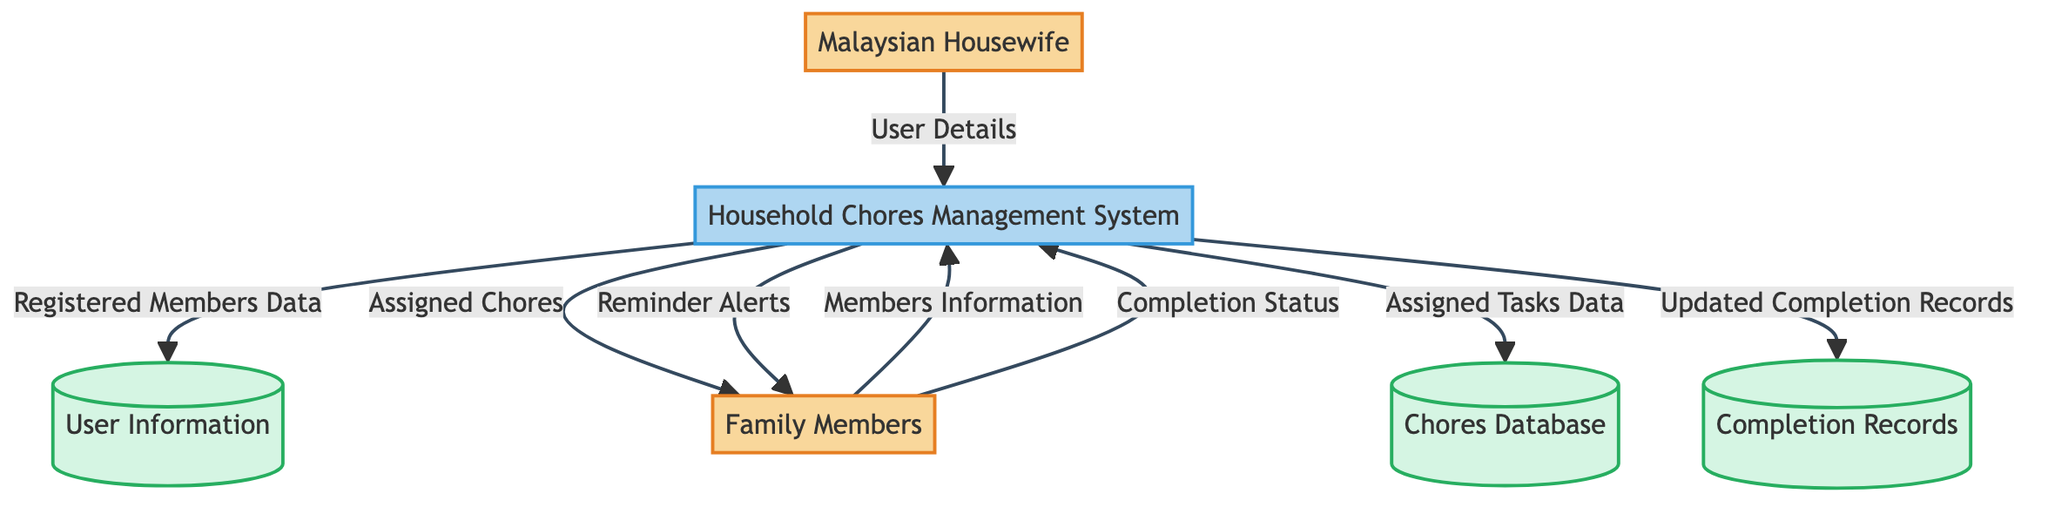What is the primary user of the system? The diagram identifies the primary user as a "Malaysian Housewife." This term is explicitly mentioned in the entity section of the Data Flow Diagram.
Answer: Malaysian Housewife How many data stores are in the diagram? The diagram shows three distinct data stores: "User Information," "Chores Database," and "Completion Records." By counting these, we see there are three.
Answer: 3 Who is responsible for assigning chores? The "Household Chores Management System" is responsible for assigning chores, as indicated by the flow from the system to "Household Members" labeled "Assigned Chores."
Answer: Household Chores Management System What data flows from Household Members to Task Manager? The flow named "Completion Status" moves from "Household Members" to the "Task Manager," indicating that this data is returned to the system for further processing.
Answer: Completion Status What type of alerts does the system send to Household Members? The flow labeled "Reminder Alerts" shows that the system sends reminders to Household Members. This is explicitly stated in the diagram.
Answer: Reminder Alerts Which process updates the completion records? The process responsible for updating the completion records is "Track Task Completion." This is derived from the flow linking the completion status to the task manager, ultimately leading to updated records.
Answer: Track Task Completion Which entity sends user details to the Task Manager? The "Malaysian Housewife" sends "User Details" to the "Household Chores Management System," as shown in the flow diagram.
Answer: Malaysian Housewife What is stored in Chores Database? The "Assigned Tasks Data" is stored in the "Chores Database," which is indicated by the flow coming from the Task Manager to the database.
Answer: Assigned Tasks Data From where does the Task Manager receive members information? The Task Manager receives "Members Information" from "Family Members," as depicted by the directed flow in the diagram.
Answer: Family Members 